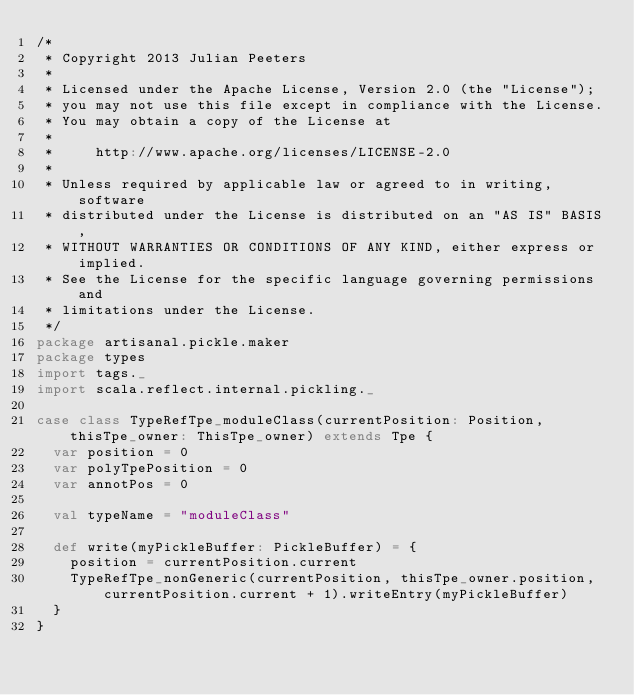Convert code to text. <code><loc_0><loc_0><loc_500><loc_500><_Scala_>/*
 * Copyright 2013 Julian Peeters
 *   
 * Licensed under the Apache License, Version 2.0 (the "License");
 * you may not use this file except in compliance with the License.
 * You may obtain a copy of the License at
 * 
 *     http://www.apache.org/licenses/LICENSE-2.0
 * 
 * Unless required by applicable law or agreed to in writing, software
 * distributed under the License is distributed on an "AS IS" BASIS,
 * WITHOUT WARRANTIES OR CONDITIONS OF ANY KIND, either express or implied.
 * See the License for the specific language governing permissions and
 * limitations under the License.
 */
package artisanal.pickle.maker 
package types
import tags._
import scala.reflect.internal.pickling._

case class TypeRefTpe_moduleClass(currentPosition: Position, thisTpe_owner: ThisTpe_owner) extends Tpe {
  var position = 0
  var polyTpePosition = 0
  var annotPos = 0

  val typeName = "moduleClass"

  def write(myPickleBuffer: PickleBuffer) = {
    position = currentPosition.current
    TypeRefTpe_nonGeneric(currentPosition, thisTpe_owner.position, currentPosition.current + 1).writeEntry(myPickleBuffer)
  }
}
</code> 